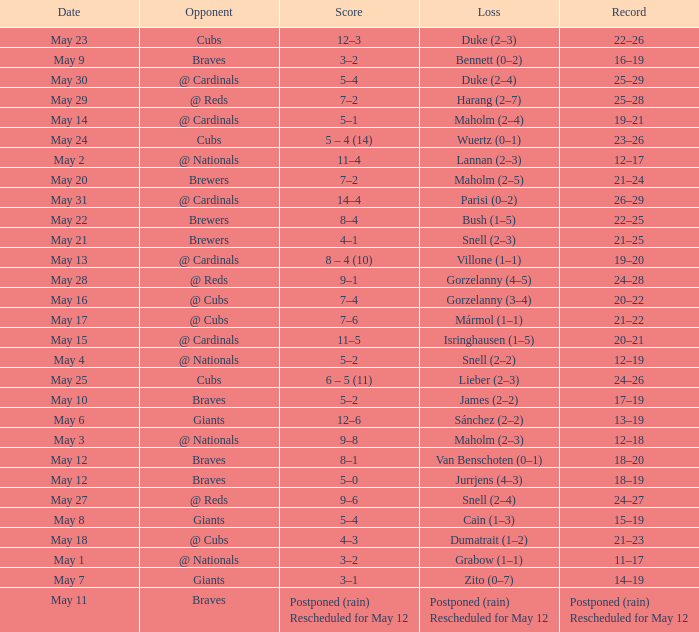What was the date of the game with a loss of Bush (1–5)? May 22. 